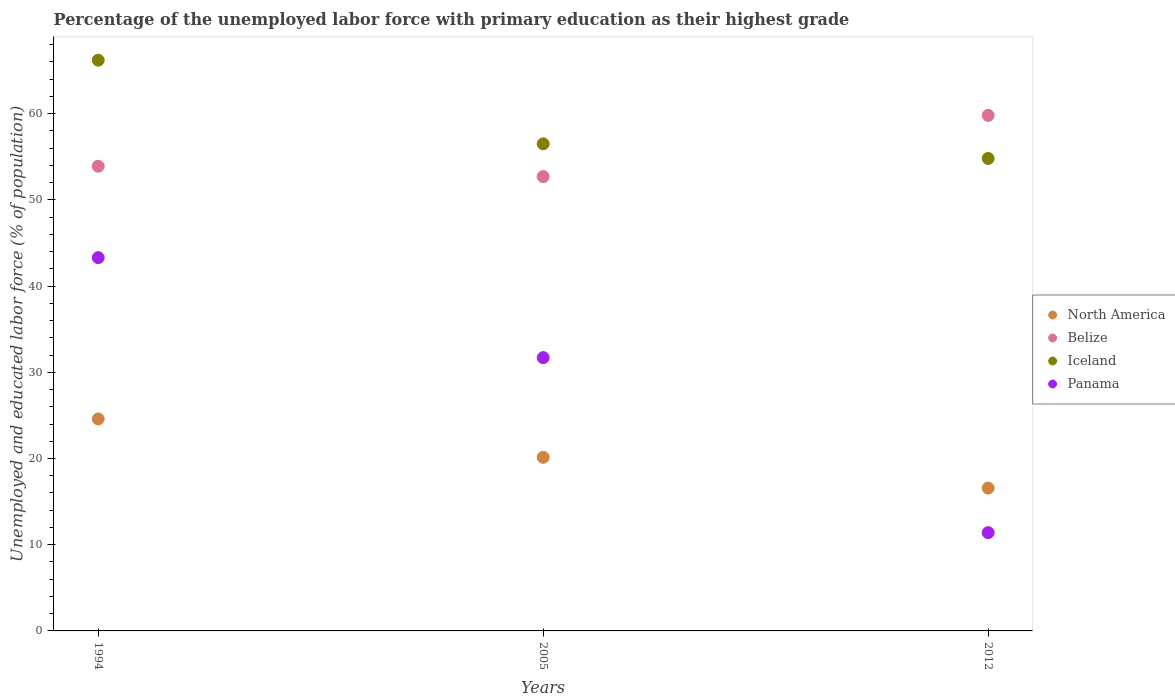What is the percentage of the unemployed labor force with primary education in North America in 2012?
Your answer should be compact. 16.56. Across all years, what is the maximum percentage of the unemployed labor force with primary education in North America?
Make the answer very short. 24.59. Across all years, what is the minimum percentage of the unemployed labor force with primary education in Panama?
Your response must be concise. 11.4. What is the total percentage of the unemployed labor force with primary education in Panama in the graph?
Your response must be concise. 86.4. What is the difference between the percentage of the unemployed labor force with primary education in Belize in 1994 and that in 2012?
Provide a succinct answer. -5.9. What is the difference between the percentage of the unemployed labor force with primary education in Belize in 1994 and the percentage of the unemployed labor force with primary education in Iceland in 2012?
Keep it short and to the point. -0.9. What is the average percentage of the unemployed labor force with primary education in Panama per year?
Your answer should be very brief. 28.8. In the year 2005, what is the difference between the percentage of the unemployed labor force with primary education in Panama and percentage of the unemployed labor force with primary education in Belize?
Your answer should be very brief. -21. In how many years, is the percentage of the unemployed labor force with primary education in North America greater than 52 %?
Provide a short and direct response. 0. What is the ratio of the percentage of the unemployed labor force with primary education in Belize in 1994 to that in 2012?
Provide a succinct answer. 0.9. Is the difference between the percentage of the unemployed labor force with primary education in Panama in 2005 and 2012 greater than the difference between the percentage of the unemployed labor force with primary education in Belize in 2005 and 2012?
Your answer should be compact. Yes. What is the difference between the highest and the second highest percentage of the unemployed labor force with primary education in North America?
Provide a succinct answer. 4.45. What is the difference between the highest and the lowest percentage of the unemployed labor force with primary education in Panama?
Offer a terse response. 31.9. In how many years, is the percentage of the unemployed labor force with primary education in Belize greater than the average percentage of the unemployed labor force with primary education in Belize taken over all years?
Your response must be concise. 1. Is the sum of the percentage of the unemployed labor force with primary education in Panama in 1994 and 2012 greater than the maximum percentage of the unemployed labor force with primary education in Iceland across all years?
Your answer should be very brief. No. Is it the case that in every year, the sum of the percentage of the unemployed labor force with primary education in Iceland and percentage of the unemployed labor force with primary education in Panama  is greater than the sum of percentage of the unemployed labor force with primary education in Belize and percentage of the unemployed labor force with primary education in North America?
Ensure brevity in your answer.  No. Does the percentage of the unemployed labor force with primary education in North America monotonically increase over the years?
Your answer should be very brief. No. Is the percentage of the unemployed labor force with primary education in Panama strictly greater than the percentage of the unemployed labor force with primary education in Iceland over the years?
Your response must be concise. No. How many dotlines are there?
Ensure brevity in your answer.  4. What is the difference between two consecutive major ticks on the Y-axis?
Your answer should be compact. 10. Are the values on the major ticks of Y-axis written in scientific E-notation?
Provide a short and direct response. No. Does the graph contain any zero values?
Ensure brevity in your answer.  No. How many legend labels are there?
Your response must be concise. 4. What is the title of the graph?
Make the answer very short. Percentage of the unemployed labor force with primary education as their highest grade. What is the label or title of the X-axis?
Ensure brevity in your answer.  Years. What is the label or title of the Y-axis?
Your answer should be compact. Unemployed and educated labor force (% of population). What is the Unemployed and educated labor force (% of population) in North America in 1994?
Provide a short and direct response. 24.59. What is the Unemployed and educated labor force (% of population) of Belize in 1994?
Your answer should be very brief. 53.9. What is the Unemployed and educated labor force (% of population) in Iceland in 1994?
Your answer should be very brief. 66.2. What is the Unemployed and educated labor force (% of population) in Panama in 1994?
Provide a succinct answer. 43.3. What is the Unemployed and educated labor force (% of population) in North America in 2005?
Give a very brief answer. 20.14. What is the Unemployed and educated labor force (% of population) of Belize in 2005?
Your answer should be very brief. 52.7. What is the Unemployed and educated labor force (% of population) in Iceland in 2005?
Offer a very short reply. 56.5. What is the Unemployed and educated labor force (% of population) in Panama in 2005?
Provide a short and direct response. 31.7. What is the Unemployed and educated labor force (% of population) of North America in 2012?
Offer a terse response. 16.56. What is the Unemployed and educated labor force (% of population) in Belize in 2012?
Ensure brevity in your answer.  59.8. What is the Unemployed and educated labor force (% of population) in Iceland in 2012?
Ensure brevity in your answer.  54.8. What is the Unemployed and educated labor force (% of population) in Panama in 2012?
Ensure brevity in your answer.  11.4. Across all years, what is the maximum Unemployed and educated labor force (% of population) of North America?
Provide a succinct answer. 24.59. Across all years, what is the maximum Unemployed and educated labor force (% of population) in Belize?
Provide a short and direct response. 59.8. Across all years, what is the maximum Unemployed and educated labor force (% of population) of Iceland?
Keep it short and to the point. 66.2. Across all years, what is the maximum Unemployed and educated labor force (% of population) of Panama?
Ensure brevity in your answer.  43.3. Across all years, what is the minimum Unemployed and educated labor force (% of population) in North America?
Provide a succinct answer. 16.56. Across all years, what is the minimum Unemployed and educated labor force (% of population) of Belize?
Make the answer very short. 52.7. Across all years, what is the minimum Unemployed and educated labor force (% of population) in Iceland?
Make the answer very short. 54.8. Across all years, what is the minimum Unemployed and educated labor force (% of population) in Panama?
Provide a short and direct response. 11.4. What is the total Unemployed and educated labor force (% of population) of North America in the graph?
Provide a succinct answer. 61.29. What is the total Unemployed and educated labor force (% of population) of Belize in the graph?
Your answer should be very brief. 166.4. What is the total Unemployed and educated labor force (% of population) of Iceland in the graph?
Provide a short and direct response. 177.5. What is the total Unemployed and educated labor force (% of population) in Panama in the graph?
Your response must be concise. 86.4. What is the difference between the Unemployed and educated labor force (% of population) in North America in 1994 and that in 2005?
Ensure brevity in your answer.  4.45. What is the difference between the Unemployed and educated labor force (% of population) in Panama in 1994 and that in 2005?
Provide a succinct answer. 11.6. What is the difference between the Unemployed and educated labor force (% of population) in North America in 1994 and that in 2012?
Offer a very short reply. 8.03. What is the difference between the Unemployed and educated labor force (% of population) in Iceland in 1994 and that in 2012?
Your answer should be very brief. 11.4. What is the difference between the Unemployed and educated labor force (% of population) in Panama in 1994 and that in 2012?
Keep it short and to the point. 31.9. What is the difference between the Unemployed and educated labor force (% of population) of North America in 2005 and that in 2012?
Your answer should be compact. 3.58. What is the difference between the Unemployed and educated labor force (% of population) in Belize in 2005 and that in 2012?
Give a very brief answer. -7.1. What is the difference between the Unemployed and educated labor force (% of population) in Panama in 2005 and that in 2012?
Offer a terse response. 20.3. What is the difference between the Unemployed and educated labor force (% of population) of North America in 1994 and the Unemployed and educated labor force (% of population) of Belize in 2005?
Offer a very short reply. -28.11. What is the difference between the Unemployed and educated labor force (% of population) of North America in 1994 and the Unemployed and educated labor force (% of population) of Iceland in 2005?
Ensure brevity in your answer.  -31.91. What is the difference between the Unemployed and educated labor force (% of population) of North America in 1994 and the Unemployed and educated labor force (% of population) of Panama in 2005?
Your answer should be compact. -7.11. What is the difference between the Unemployed and educated labor force (% of population) in Belize in 1994 and the Unemployed and educated labor force (% of population) in Iceland in 2005?
Your response must be concise. -2.6. What is the difference between the Unemployed and educated labor force (% of population) of Iceland in 1994 and the Unemployed and educated labor force (% of population) of Panama in 2005?
Offer a terse response. 34.5. What is the difference between the Unemployed and educated labor force (% of population) in North America in 1994 and the Unemployed and educated labor force (% of population) in Belize in 2012?
Offer a very short reply. -35.21. What is the difference between the Unemployed and educated labor force (% of population) of North America in 1994 and the Unemployed and educated labor force (% of population) of Iceland in 2012?
Offer a very short reply. -30.21. What is the difference between the Unemployed and educated labor force (% of population) in North America in 1994 and the Unemployed and educated labor force (% of population) in Panama in 2012?
Your answer should be very brief. 13.19. What is the difference between the Unemployed and educated labor force (% of population) of Belize in 1994 and the Unemployed and educated labor force (% of population) of Iceland in 2012?
Keep it short and to the point. -0.9. What is the difference between the Unemployed and educated labor force (% of population) in Belize in 1994 and the Unemployed and educated labor force (% of population) in Panama in 2012?
Give a very brief answer. 42.5. What is the difference between the Unemployed and educated labor force (% of population) of Iceland in 1994 and the Unemployed and educated labor force (% of population) of Panama in 2012?
Ensure brevity in your answer.  54.8. What is the difference between the Unemployed and educated labor force (% of population) of North America in 2005 and the Unemployed and educated labor force (% of population) of Belize in 2012?
Offer a very short reply. -39.66. What is the difference between the Unemployed and educated labor force (% of population) in North America in 2005 and the Unemployed and educated labor force (% of population) in Iceland in 2012?
Your answer should be compact. -34.66. What is the difference between the Unemployed and educated labor force (% of population) of North America in 2005 and the Unemployed and educated labor force (% of population) of Panama in 2012?
Your response must be concise. 8.74. What is the difference between the Unemployed and educated labor force (% of population) of Belize in 2005 and the Unemployed and educated labor force (% of population) of Iceland in 2012?
Offer a terse response. -2.1. What is the difference between the Unemployed and educated labor force (% of population) in Belize in 2005 and the Unemployed and educated labor force (% of population) in Panama in 2012?
Give a very brief answer. 41.3. What is the difference between the Unemployed and educated labor force (% of population) in Iceland in 2005 and the Unemployed and educated labor force (% of population) in Panama in 2012?
Your answer should be very brief. 45.1. What is the average Unemployed and educated labor force (% of population) of North America per year?
Offer a very short reply. 20.43. What is the average Unemployed and educated labor force (% of population) of Belize per year?
Keep it short and to the point. 55.47. What is the average Unemployed and educated labor force (% of population) of Iceland per year?
Offer a terse response. 59.17. What is the average Unemployed and educated labor force (% of population) in Panama per year?
Your answer should be very brief. 28.8. In the year 1994, what is the difference between the Unemployed and educated labor force (% of population) in North America and Unemployed and educated labor force (% of population) in Belize?
Your answer should be very brief. -29.31. In the year 1994, what is the difference between the Unemployed and educated labor force (% of population) of North America and Unemployed and educated labor force (% of population) of Iceland?
Offer a terse response. -41.61. In the year 1994, what is the difference between the Unemployed and educated labor force (% of population) in North America and Unemployed and educated labor force (% of population) in Panama?
Make the answer very short. -18.71. In the year 1994, what is the difference between the Unemployed and educated labor force (% of population) in Belize and Unemployed and educated labor force (% of population) in Iceland?
Your response must be concise. -12.3. In the year 1994, what is the difference between the Unemployed and educated labor force (% of population) of Belize and Unemployed and educated labor force (% of population) of Panama?
Make the answer very short. 10.6. In the year 1994, what is the difference between the Unemployed and educated labor force (% of population) in Iceland and Unemployed and educated labor force (% of population) in Panama?
Offer a very short reply. 22.9. In the year 2005, what is the difference between the Unemployed and educated labor force (% of population) in North America and Unemployed and educated labor force (% of population) in Belize?
Your response must be concise. -32.56. In the year 2005, what is the difference between the Unemployed and educated labor force (% of population) of North America and Unemployed and educated labor force (% of population) of Iceland?
Your answer should be compact. -36.36. In the year 2005, what is the difference between the Unemployed and educated labor force (% of population) in North America and Unemployed and educated labor force (% of population) in Panama?
Offer a terse response. -11.56. In the year 2005, what is the difference between the Unemployed and educated labor force (% of population) in Belize and Unemployed and educated labor force (% of population) in Panama?
Offer a very short reply. 21. In the year 2005, what is the difference between the Unemployed and educated labor force (% of population) in Iceland and Unemployed and educated labor force (% of population) in Panama?
Offer a terse response. 24.8. In the year 2012, what is the difference between the Unemployed and educated labor force (% of population) of North America and Unemployed and educated labor force (% of population) of Belize?
Your answer should be compact. -43.24. In the year 2012, what is the difference between the Unemployed and educated labor force (% of population) in North America and Unemployed and educated labor force (% of population) in Iceland?
Provide a short and direct response. -38.24. In the year 2012, what is the difference between the Unemployed and educated labor force (% of population) in North America and Unemployed and educated labor force (% of population) in Panama?
Keep it short and to the point. 5.16. In the year 2012, what is the difference between the Unemployed and educated labor force (% of population) of Belize and Unemployed and educated labor force (% of population) of Iceland?
Give a very brief answer. 5. In the year 2012, what is the difference between the Unemployed and educated labor force (% of population) in Belize and Unemployed and educated labor force (% of population) in Panama?
Your response must be concise. 48.4. In the year 2012, what is the difference between the Unemployed and educated labor force (% of population) in Iceland and Unemployed and educated labor force (% of population) in Panama?
Give a very brief answer. 43.4. What is the ratio of the Unemployed and educated labor force (% of population) of North America in 1994 to that in 2005?
Your answer should be compact. 1.22. What is the ratio of the Unemployed and educated labor force (% of population) in Belize in 1994 to that in 2005?
Offer a very short reply. 1.02. What is the ratio of the Unemployed and educated labor force (% of population) in Iceland in 1994 to that in 2005?
Offer a terse response. 1.17. What is the ratio of the Unemployed and educated labor force (% of population) of Panama in 1994 to that in 2005?
Make the answer very short. 1.37. What is the ratio of the Unemployed and educated labor force (% of population) in North America in 1994 to that in 2012?
Offer a very short reply. 1.48. What is the ratio of the Unemployed and educated labor force (% of population) in Belize in 1994 to that in 2012?
Keep it short and to the point. 0.9. What is the ratio of the Unemployed and educated labor force (% of population) in Iceland in 1994 to that in 2012?
Your response must be concise. 1.21. What is the ratio of the Unemployed and educated labor force (% of population) in Panama in 1994 to that in 2012?
Ensure brevity in your answer.  3.8. What is the ratio of the Unemployed and educated labor force (% of population) in North America in 2005 to that in 2012?
Provide a short and direct response. 1.22. What is the ratio of the Unemployed and educated labor force (% of population) in Belize in 2005 to that in 2012?
Your answer should be very brief. 0.88. What is the ratio of the Unemployed and educated labor force (% of population) of Iceland in 2005 to that in 2012?
Your answer should be very brief. 1.03. What is the ratio of the Unemployed and educated labor force (% of population) in Panama in 2005 to that in 2012?
Your answer should be very brief. 2.78. What is the difference between the highest and the second highest Unemployed and educated labor force (% of population) of North America?
Provide a succinct answer. 4.45. What is the difference between the highest and the second highest Unemployed and educated labor force (% of population) in Panama?
Your response must be concise. 11.6. What is the difference between the highest and the lowest Unemployed and educated labor force (% of population) in North America?
Give a very brief answer. 8.03. What is the difference between the highest and the lowest Unemployed and educated labor force (% of population) in Iceland?
Offer a terse response. 11.4. What is the difference between the highest and the lowest Unemployed and educated labor force (% of population) of Panama?
Provide a short and direct response. 31.9. 